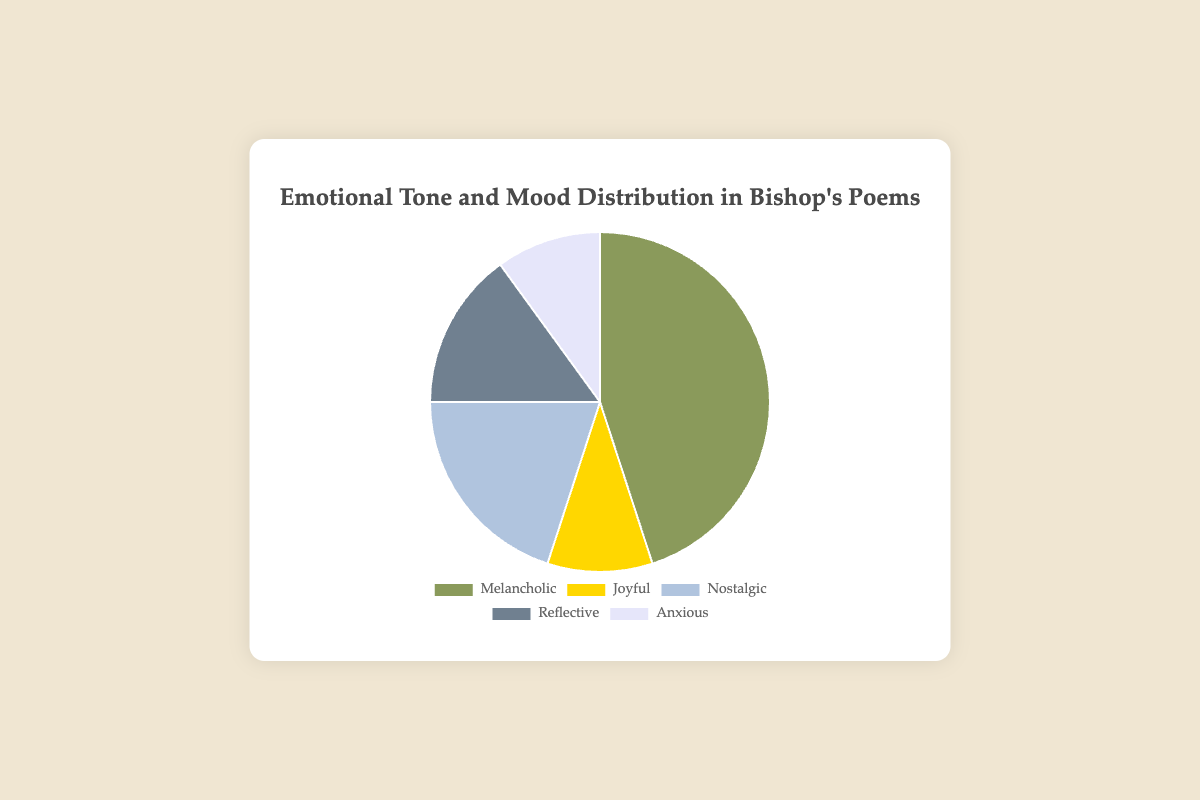What's the most dominant emotional tone in Bishop's poems? The figure shows a pie chart with different segments representing the distribution of emotional tones. The largest segment corresponds to the 'Melancholic' tone, indicating it is the most dominant.
Answer: Melancholic Which emotional tones are equally represented in Bishop's poems? By looking at the sizes of the pie chart segments, 'Joyful' and 'Anxious' both have 10% representation, showing they are equally represented.
Answer: Joyful and Anxious What percentage of Bishop's poems have a reflective or nostalgic tone combined? The pie chart shows 'Reflective' has 15% and 'Nostalgic' has 20%. Adding these percentages gives 15% + 20% = 35%.
Answer: 35% How much larger is the melancholic tone compared to the nostalgic tone? The pie chart shows 'Melancholic' at 45% and 'Nostalgic' at 20%. Subtracting these values gives 45% - 20% = 25%.
Answer: 25% Which emotional tone occupies more space on the pie chart than joyful but less than reflective? By comparing the segments, 'Nostalgic' (20%) is more than 'Joyful' (10%) and less than 'Reflective' (15%). Additionally, 'Nostalgic' fits this criteria.
Answer: Nostalgic What is the second most represented emotional tone in Bishop's poems? The pie chart shows the second largest segment is for 'Nostalgic' with 20%, following 'Melancholic' (45%).
Answer: Nostalgic What are the proportions of all emotional tones in descending order? By observing the segment sizes from largest to smallest, we get 'Melancholic' (45%), 'Nostalgic' (20%), 'Reflective' (15%), 'Joyful' (10%), 'Anxious' (10%).
Answer: Melancholic, Nostalgic, Reflective, Joyful, Anxious Which tone is depicted using a greenish color on the pie chart? The optically greenish section of the pie chart corresponds to the 'Melancholic' tone, as it occupies the largest segment.
Answer: Melancholic 